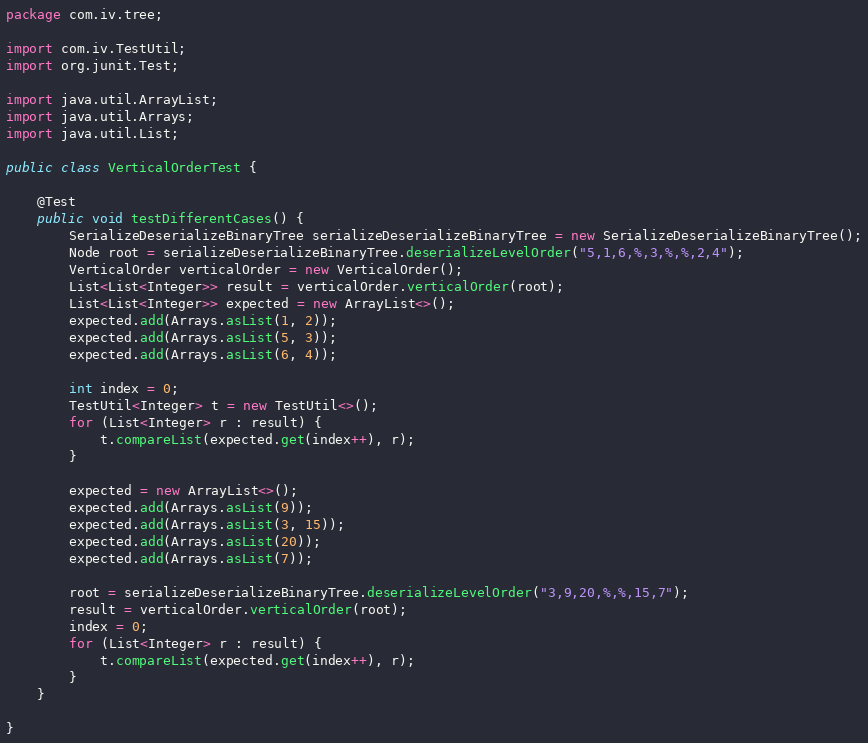<code> <loc_0><loc_0><loc_500><loc_500><_Java_>package com.iv.tree;

import com.iv.TestUtil;
import org.junit.Test;

import java.util.ArrayList;
import java.util.Arrays;
import java.util.List;

public class VerticalOrderTest {

    @Test
    public void testDifferentCases() {
        SerializeDeserializeBinaryTree serializeDeserializeBinaryTree = new SerializeDeserializeBinaryTree();
        Node root = serializeDeserializeBinaryTree.deserializeLevelOrder("5,1,6,%,3,%,%,2,4");
        VerticalOrder verticalOrder = new VerticalOrder();
        List<List<Integer>> result = verticalOrder.verticalOrder(root);
        List<List<Integer>> expected = new ArrayList<>();
        expected.add(Arrays.asList(1, 2));
        expected.add(Arrays.asList(5, 3));
        expected.add(Arrays.asList(6, 4));

        int index = 0;
        TestUtil<Integer> t = new TestUtil<>();
        for (List<Integer> r : result) {
            t.compareList(expected.get(index++), r);
        }

        expected = new ArrayList<>();
        expected.add(Arrays.asList(9));
        expected.add(Arrays.asList(3, 15));
        expected.add(Arrays.asList(20));
        expected.add(Arrays.asList(7));

        root = serializeDeserializeBinaryTree.deserializeLevelOrder("3,9,20,%,%,15,7");
        result = verticalOrder.verticalOrder(root);
        index = 0;
        for (List<Integer> r : result) {
            t.compareList(expected.get(index++), r);
        }
    }

}
</code> 